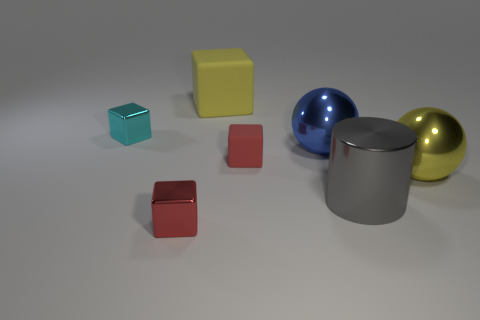Subtract all yellow blocks. How many blocks are left? 3 Subtract 1 cylinders. How many cylinders are left? 0 Add 1 yellow cubes. How many objects exist? 8 Subtract all yellow blocks. How many blocks are left? 3 Subtract all cylinders. How many objects are left? 6 Subtract all purple cubes. Subtract all gray cylinders. How many cubes are left? 4 Subtract all green spheres. How many blue cubes are left? 0 Subtract all red shiny objects. Subtract all large blue objects. How many objects are left? 5 Add 3 red objects. How many red objects are left? 5 Add 3 large yellow metallic blocks. How many large yellow metallic blocks exist? 3 